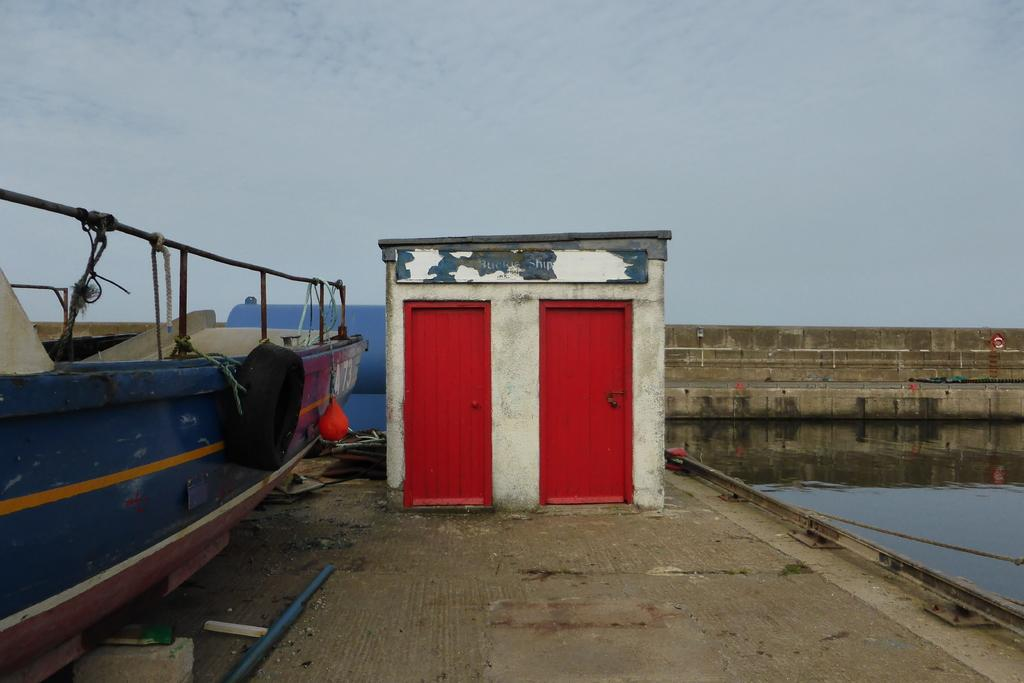What can be seen in the middle of the image? There are two red doors in the middle of the image. What is located on the left side of the image? There is a boat on the left side of the image. What is on the right side of the image? There is water on the right side of the image. What is the income of the person driving the car in the image? There is no car present in the image, so it is not possible to determine the income of the person driving it. 